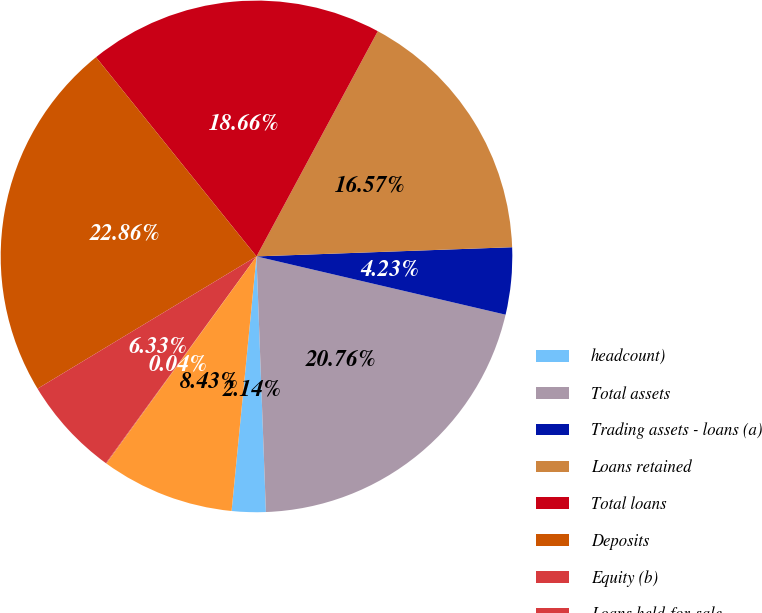Convert chart to OTSL. <chart><loc_0><loc_0><loc_500><loc_500><pie_chart><fcel>headcount)<fcel>Total assets<fcel>Trading assets - loans (a)<fcel>Loans retained<fcel>Total loans<fcel>Deposits<fcel>Equity (b)<fcel>Loans held-for-sale<fcel>Headcount<nl><fcel>2.14%<fcel>20.76%<fcel>4.23%<fcel>16.57%<fcel>18.66%<fcel>22.86%<fcel>6.33%<fcel>0.04%<fcel>8.43%<nl></chart> 